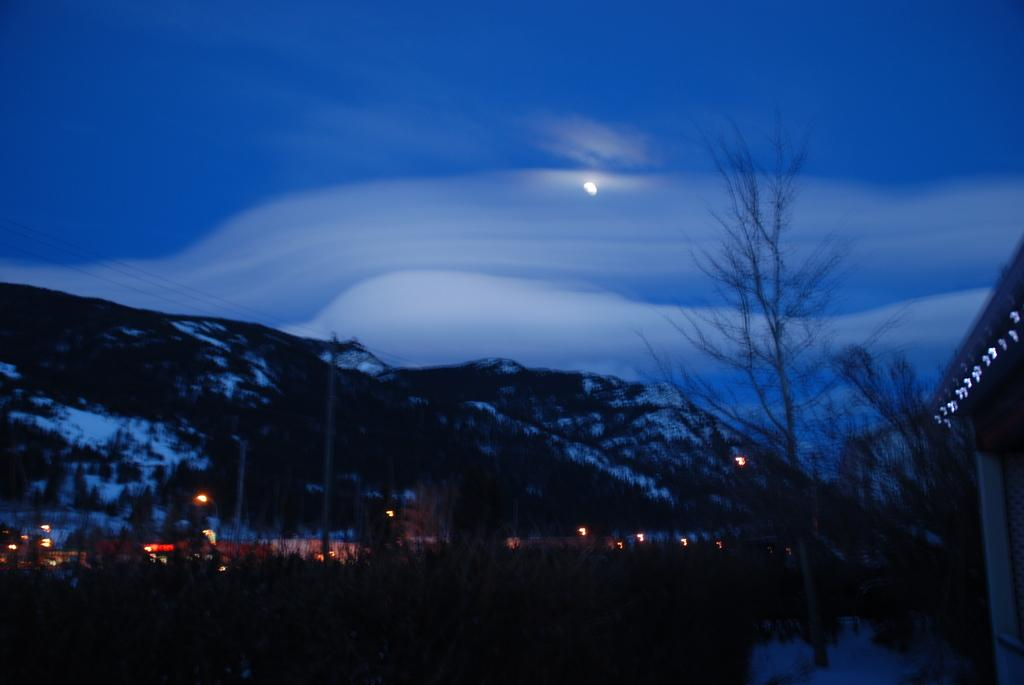What geographical feature is located in the center of the image? There are hills in the center of the image. What type of vegetation can be seen at the bottom of the image? Trees are visible at the bottom of the image. What man-made structures are present at the bottom of the image? Lights and poles are present at the bottom of the image. What type of transportation is visible at the bottom of the image? Vehicles are visible at the bottom of the image. What natural phenomenon is present at the bottom of the image? Snow is present at the bottom of the image. What can be seen in the background of the image? The sky is visible in the background of the image. What type of metal is used to create the pencil in the image? There is no pencil present in the image, so it is not possible to determine the type of metal used to create it. 